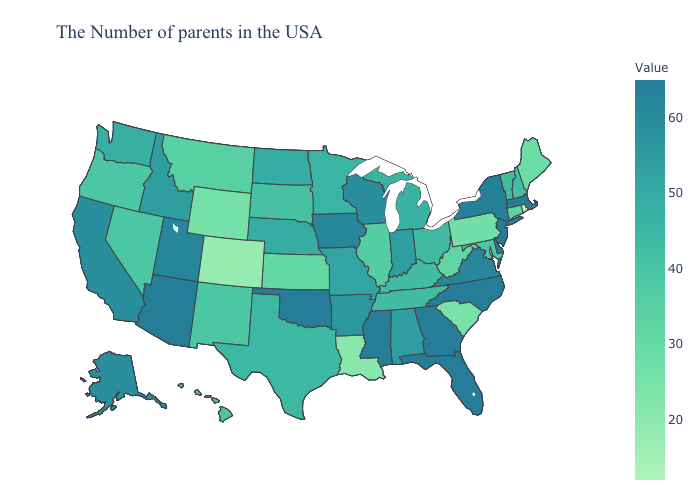Which states have the highest value in the USA?
Write a very short answer. Massachusetts, New Jersey, Delaware, North Carolina, Florida, Georgia, Mississippi, Oklahoma, Arizona. Does Florida have the highest value in the South?
Write a very short answer. Yes. Does the map have missing data?
Short answer required. No. Does Arizona have the highest value in the West?
Short answer required. Yes. Does Iowa have the highest value in the MidWest?
Answer briefly. Yes. Does Illinois have a higher value than Texas?
Write a very short answer. No. Which states have the highest value in the USA?
Concise answer only. Massachusetts, New Jersey, Delaware, North Carolina, Florida, Georgia, Mississippi, Oklahoma, Arizona. 